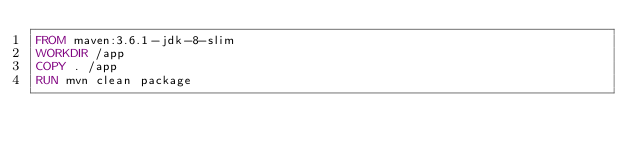<code> <loc_0><loc_0><loc_500><loc_500><_Dockerfile_>FROM maven:3.6.1-jdk-8-slim
WORKDIR /app
COPY . /app
RUN mvn clean package
</code> 